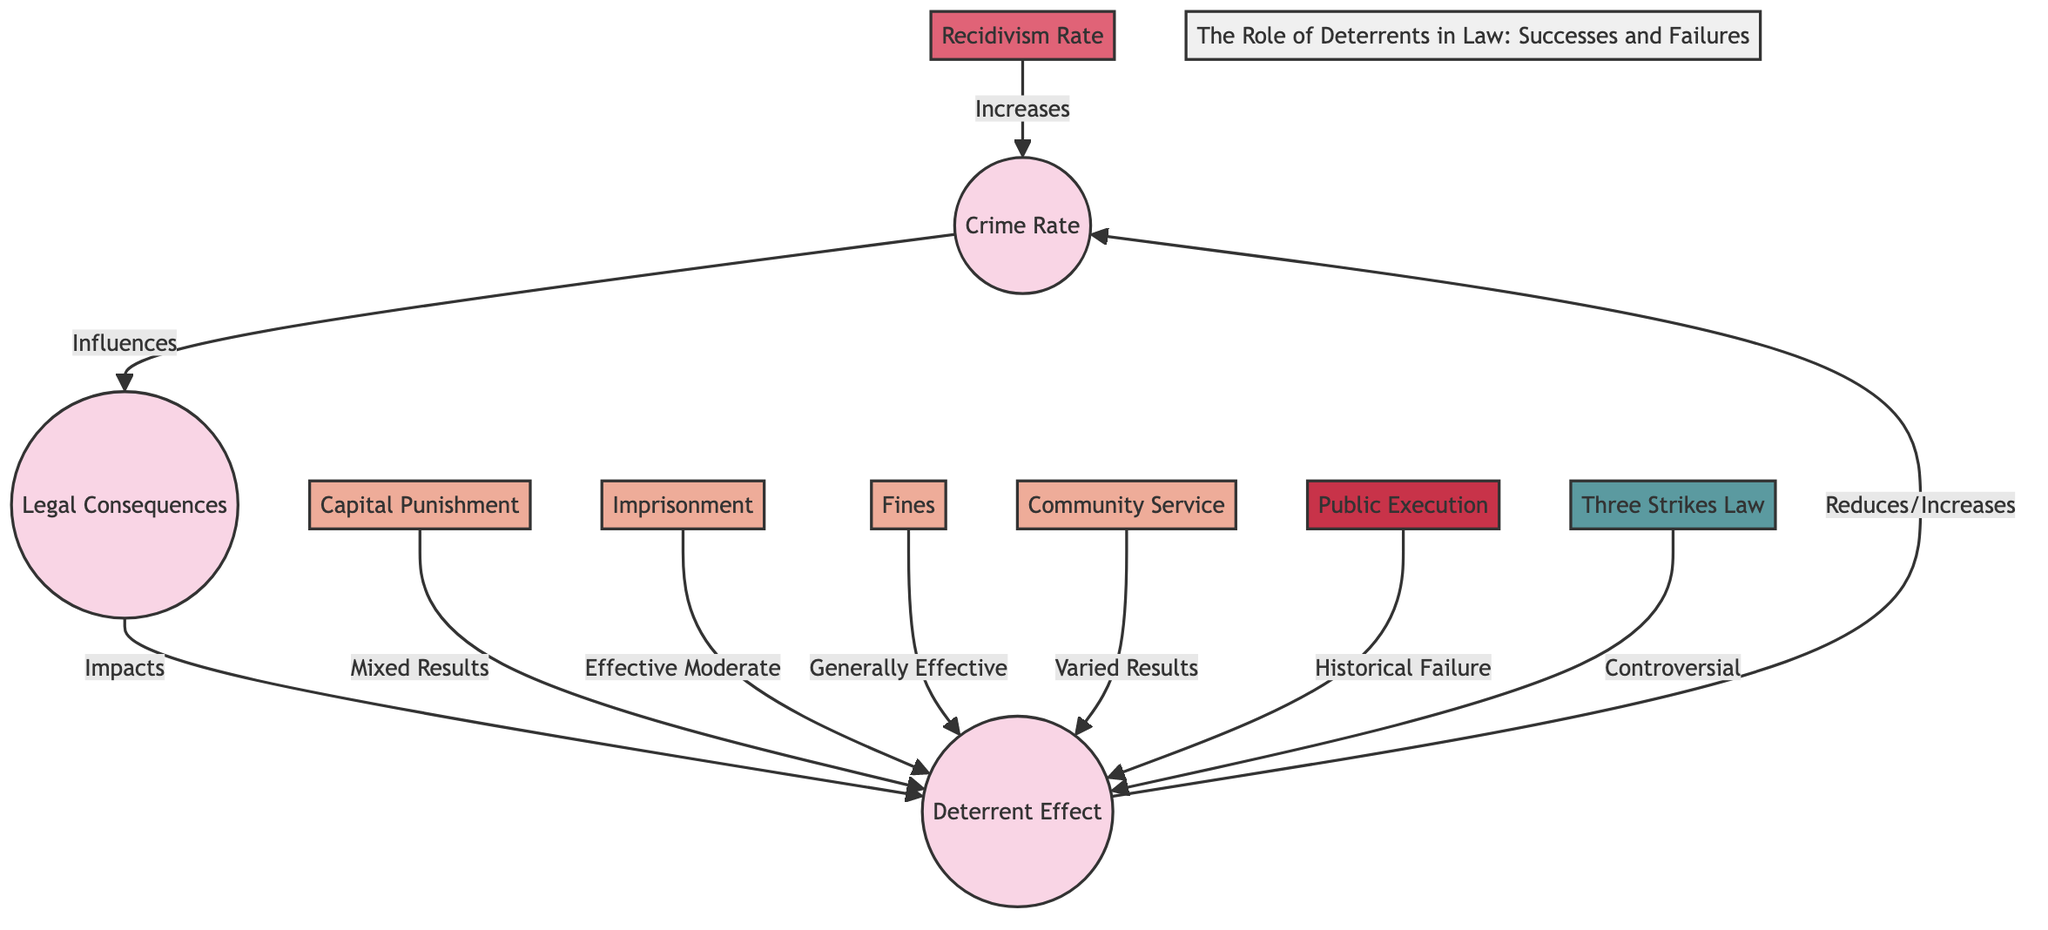What is the total number of nodes in the diagram? The nodes in the diagram include "Crime Rate," "Legal Consequences," "Deterrent Effect," "Capital Punishment," "Imprisonment," "Fines," "Recidivism Rate," "Community Service," "Public Execution," and "Three Strikes Law." Counting these gives us a total of 10 nodes.
Answer: 10 What legal consequence is indicated as having "Mixed Results"? The diagram includes "Capital Punishment," which is explicitly labeled with "Mixed Results" in the relationship leading to "Deterrent Effect."
Answer: Capital Punishment How does "Community Service" affect the deterrent effect? The diagram shows that "Community Service" leads to "Deterrent Effect" with the label "Varied Results," indicating that its impact is not consistent across different cases.
Answer: Varied Results Which consequence is classified as "Generally Effective"? In the diagram, the node "Fines" is noted for having a "Generally Effective" impact on the "Deterrent Effect" relationship.
Answer: Fines What relationship connects "Recidivism Rate" to "Crime Rate"? The diagram clearly illustrates an increase from "Recidivism Rate" to "Crime Rate," denoting that higher recidivism contributes to rising crime rates.
Answer: Increases Which legal consequence has a status described as "Historical Failure"? "Public Execution" is identified in the diagram as having a connection that denotes it as a "Historical Failure" regarding its effectiveness in deterrence.
Answer: Public Execution How does "Imprisonment" influence the deterrent effect? The relationship shows that "Imprisonment" is labeled as "Effective Moderate," indicating that it provides a substantial but not absolute deterrent effect on crime prevention.
Answer: Effective Moderate What type of law is described as "Controversial" in its effect on deterrents? The diagram indicates that the "Three Strikes Law" is classified as "Controversial" in terms of its impact on deterring crime.
Answer: Three Strikes Law What is the outcome of the connection between "Deterrent Effect" and "Crime Rate"? The diagram illustrates that the "Deterrent Effect" can either reduce or increase the "Crime Rate," implying that its impact can vary based on the circumstances surrounding each specific legal consequence.
Answer: Reduces/Increases 